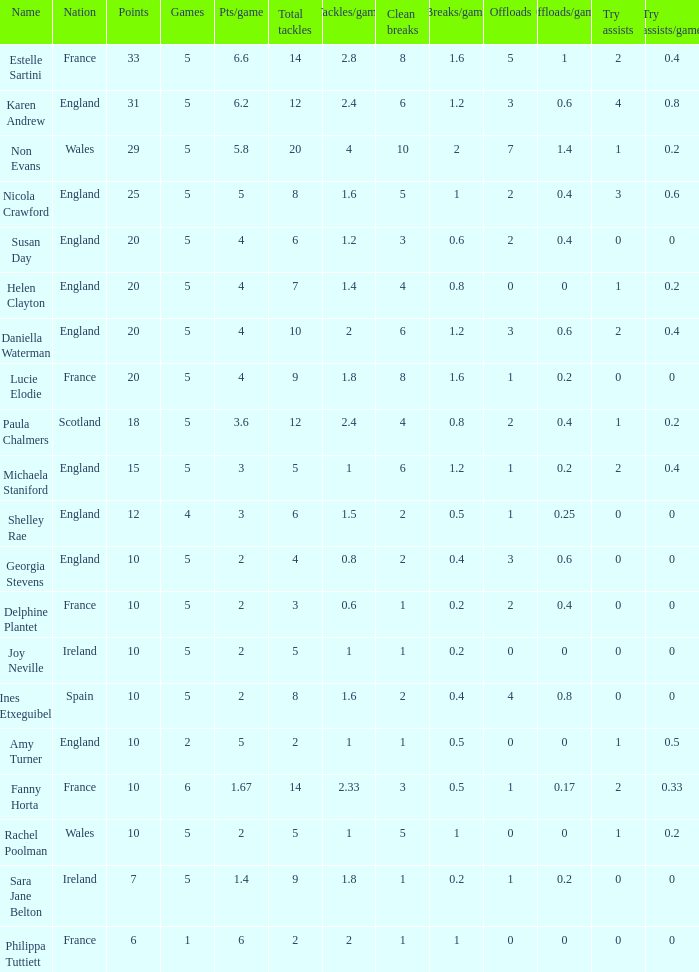Can you tell me the lowest Pts/game that has the Games larger than 6? None. 